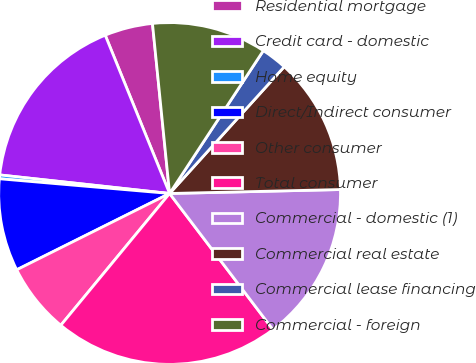Convert chart. <chart><loc_0><loc_0><loc_500><loc_500><pie_chart><fcel>Residential mortgage<fcel>Credit card - domestic<fcel>Home equity<fcel>Direct/Indirect consumer<fcel>Other consumer<fcel>Total consumer<fcel>Commercial - domestic (1)<fcel>Commercial real estate<fcel>Commercial lease financing<fcel>Commercial - foreign<nl><fcel>4.55%<fcel>17.12%<fcel>0.36%<fcel>8.74%<fcel>6.65%<fcel>21.32%<fcel>15.03%<fcel>12.93%<fcel>2.46%<fcel>10.84%<nl></chart> 